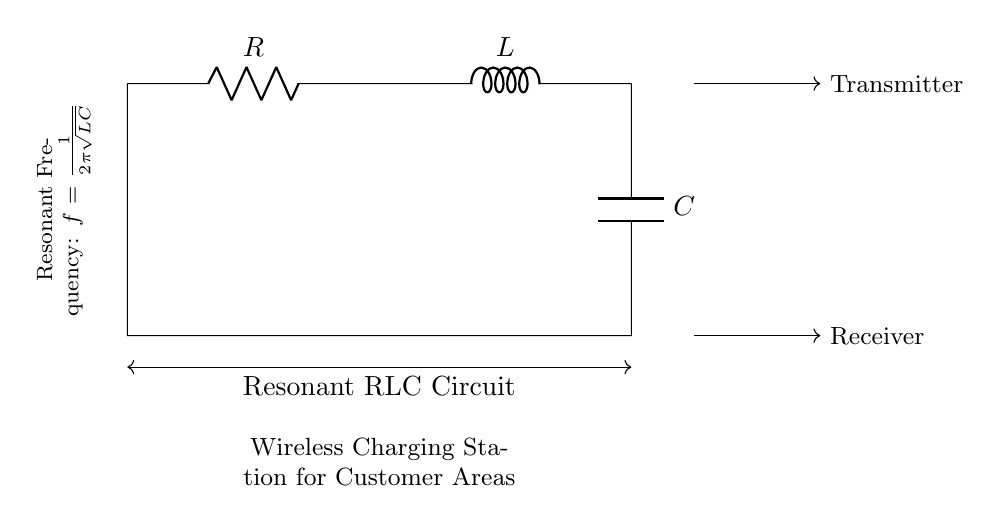What components are present in this circuit? The circuit includes a resistor, inductor, and capacitor, which are essential components of an RLC circuit and are labeled as R, L, and C in the diagram.
Answer: Resistor, Inductor, Capacitor What is the purpose of this circuit? The diagram indicates that this is a resonant RLC circuit used for a wireless charging station, as labeled underneath the circuit.
Answer: Wireless Charging Station What does the resonant frequency formula represent? The formula f = 1/(2π√(LC)) shows how the resonant frequency of the circuit is determined by the inductance (L) and capacitance (C). It implies that changing either component affects the frequency at which the circuit resonates.
Answer: Frequency formula relates L and C How do you determine the resonant frequency in this circuit? To find the resonant frequency, identify the values of L (inductance) and C (capacitance) from the circuit. The resonant frequency is calculated using the formula f = 1/(2π√(LC)), where you substitute those values in.
Answer: Substituting L and C into the frequency formula What is the connection type of the components? The diagram illustrates a series connection, where the resistor, inductor, and capacitor are connected end-to-end, indicating they share the same current throughout the circuit.
Answer: Series connection Which direction does the current flow in this circuit? The arrows indicate that the current flows from the transmitter to the receiver through the components, suggesting a unidirectional flow consistent with typical circuit behavior.
Answer: Transmitter to Receiver What is the effect of increasing the resistance on the quality factor of the circuit? Increasing resistance lowers the quality factor (Q) of the circuit because the Q factor is inversely proportional to resistance, which affects energy losses and resonance sharpness in the circuit.
Answer: Decreases the quality factor 